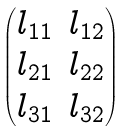<formula> <loc_0><loc_0><loc_500><loc_500>\begin{pmatrix} l _ { 1 1 } & l _ { 1 2 } \\ l _ { 2 1 } & l _ { 2 2 } \\ l _ { 3 1 } & l _ { 3 2 } \end{pmatrix}</formula> 